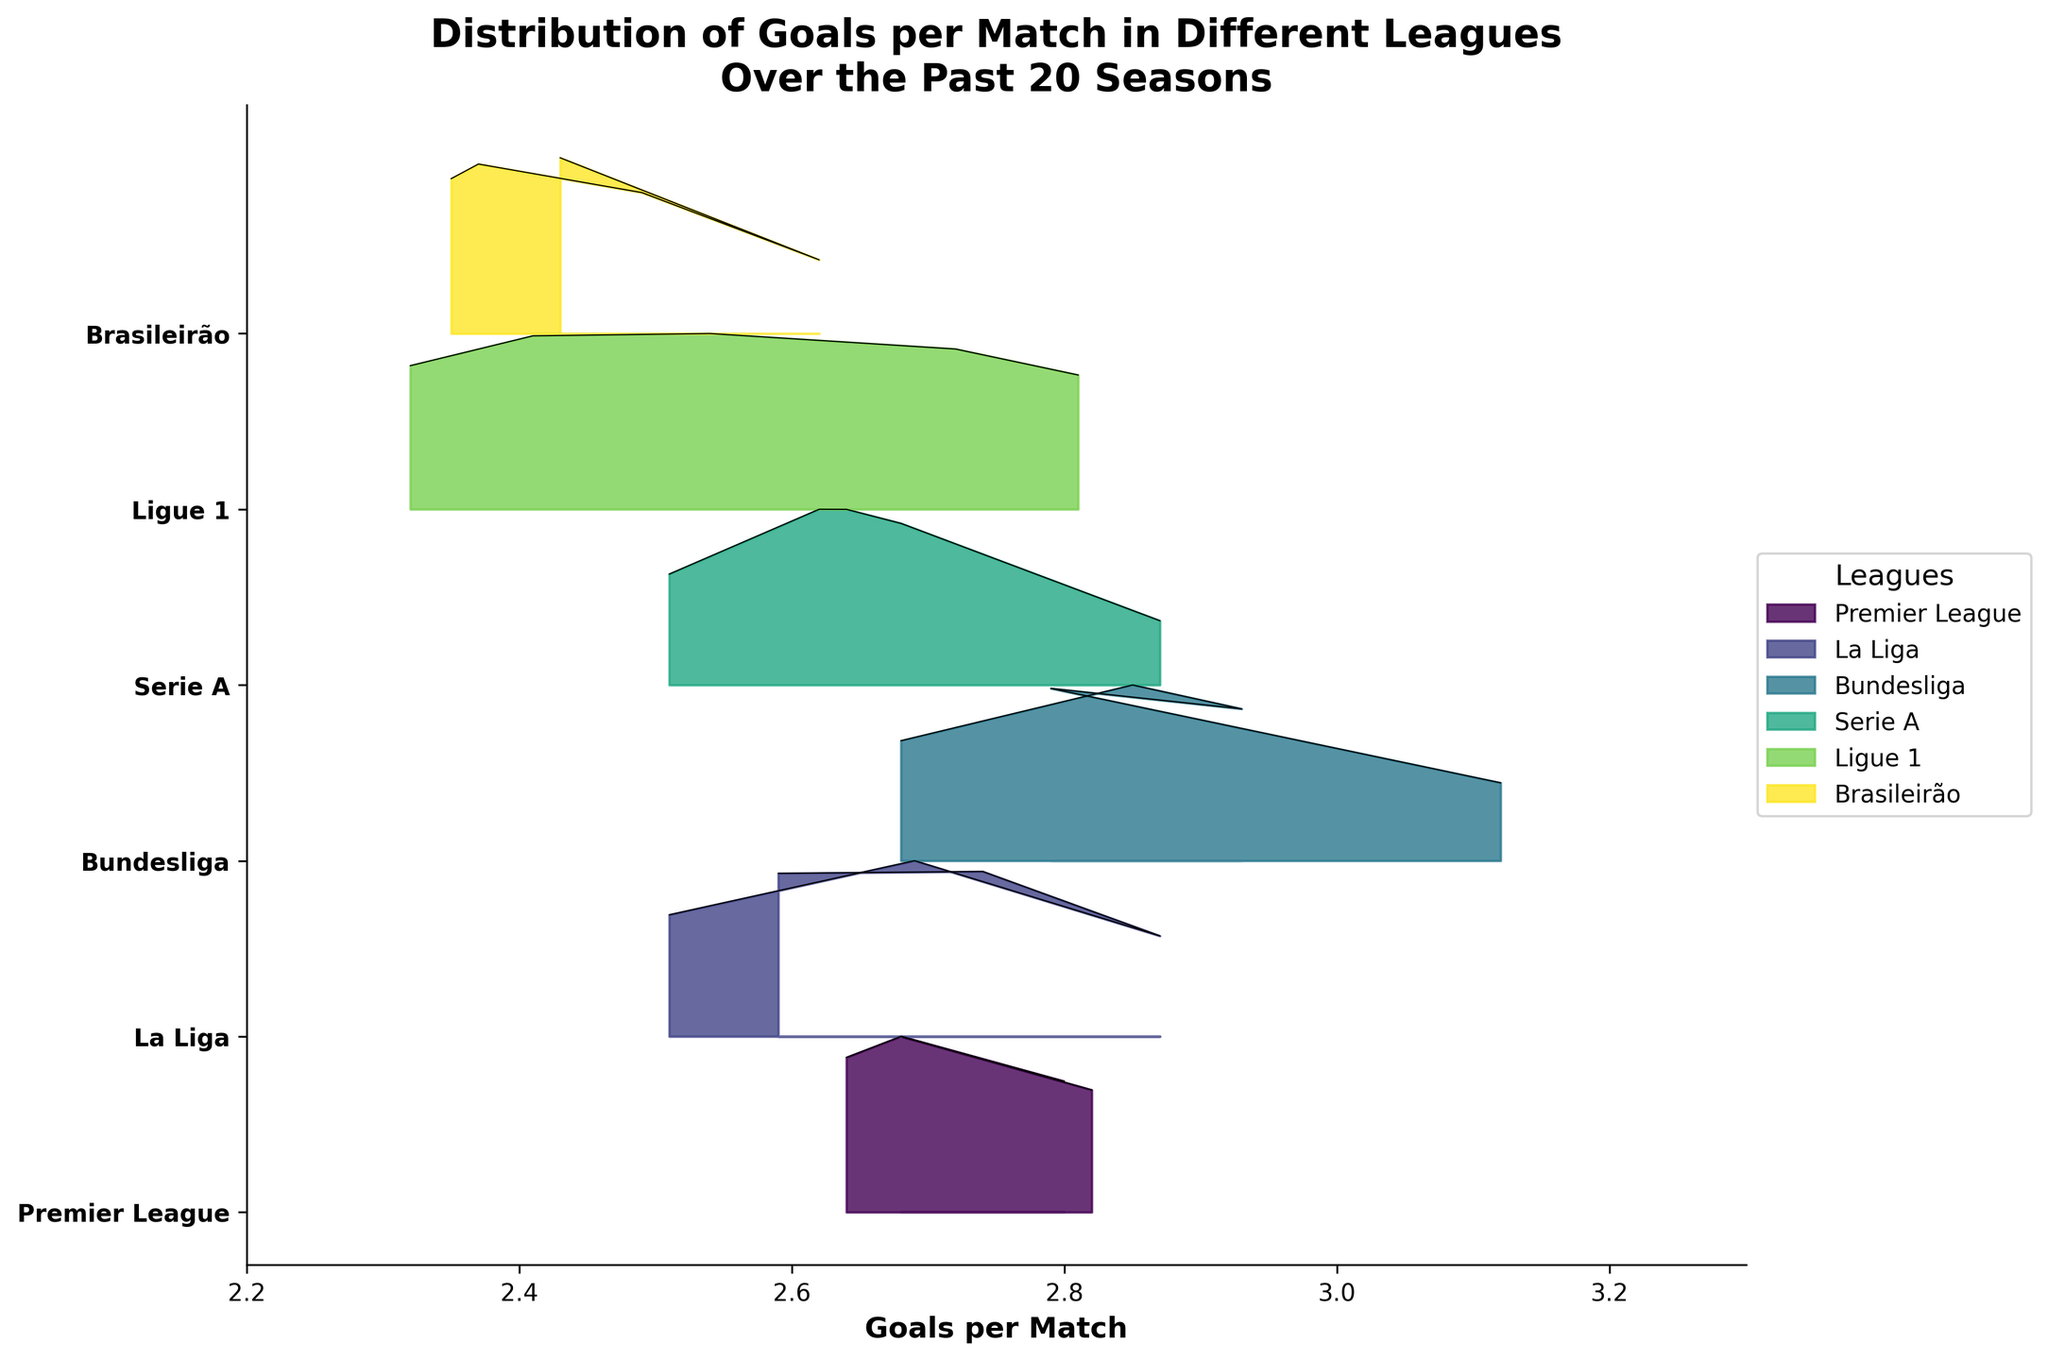What is the title of the figure? The title is usually displayed at the top of the figure. It provides a summary of what the plot is showing. Here, the title reads: "Distribution of Goals per Match in Different Leagues Over the Past 20 Seasons".
Answer: Distribution of Goals per Match in Different Leagues Over the Past 20 Seasons Which league has the highest value of goals per match in the 2021-22 season? In a Ridgeline plot, the height and the spread of the curves show the distribution. The Bundesliga’s curve in 2021-22 reaches the highest peak, indicating it has the highest goals per match for that season.
Answer: Bundesliga What is the average goals-per-match value across all leagues in the 2002-03 season? To find the average, sum all the provided goals per match values for the 2002-03 season across all leagues, then divide by the number of leagues. Here, it involves adding the values and dividing by the number of leagues: (2.64 + 2.59 + 2.68 + 2.51 + 2.32 + 2.43) / 6.
Answer: 2.53 Between 2007-08 and 2012-13, in which league did the goals per match increase the most? Find the difference in goals per match between the two seasons for each league, then compare the differences. For example, Premier League’s change is (2.80 - 2.68), trending upwards like this for each league, specifically paying attention to the increments. Bundesliga shows the highest increase.
Answer: Bundesliga Which league has the most consistent goals per match value from 2002-03 to 2021-22? Consistency would mean the smallest range of variation. By comparing the range (difference between maximum and minimum values) of goals per match for each league over these years, the Brasileirão has the least fluctuation, implying it’s the most consistent.
Answer: Brasileirão How does the goal-scoring trend in Ligue 1 compare to Serie A from 2002-03 to 2021-22? Observing the curves of both leagues, Ligue 1 has a steeper increasing trend over the seasons, moving from 2.32 to 2.81, while Serie A has a more gradual increase, from 2.51 to 2.87. This indicates faster improvement in goals per match in Ligue 1 compared to Serie A.
Answer: Ligue 1 shows a steeper increase than Serie A How many leagues had an average goals per match greater than 2.7 in the 2007-08 season? Identifying the averages equal to or greater than 2.7 in the 2007-08 season among all leagues shows Bundesliga (2.85) and La Liga (2.74). Premier League just misses at 2.68. Therefore, two leagues meet the criteria.
Answer: 2 Which league’s goals per match decreased from 2017-18 to 2021-22? To determine this, compare the goals per match values for each league between these two seasons. La Liga shows a decrease, going from 2.69 in 2017-18 to 2.51 in 2021-22.
Answer: La Liga What can you deduce about the variation in goals per match in the Premier League based on the ridgeline plot? The uniformity of the height and thickness of the Premier League’s curves over time suggests a low variation in goals per match compared to other leagues. This implies relatively consistent scoring patterns.
Answer: Low variation 